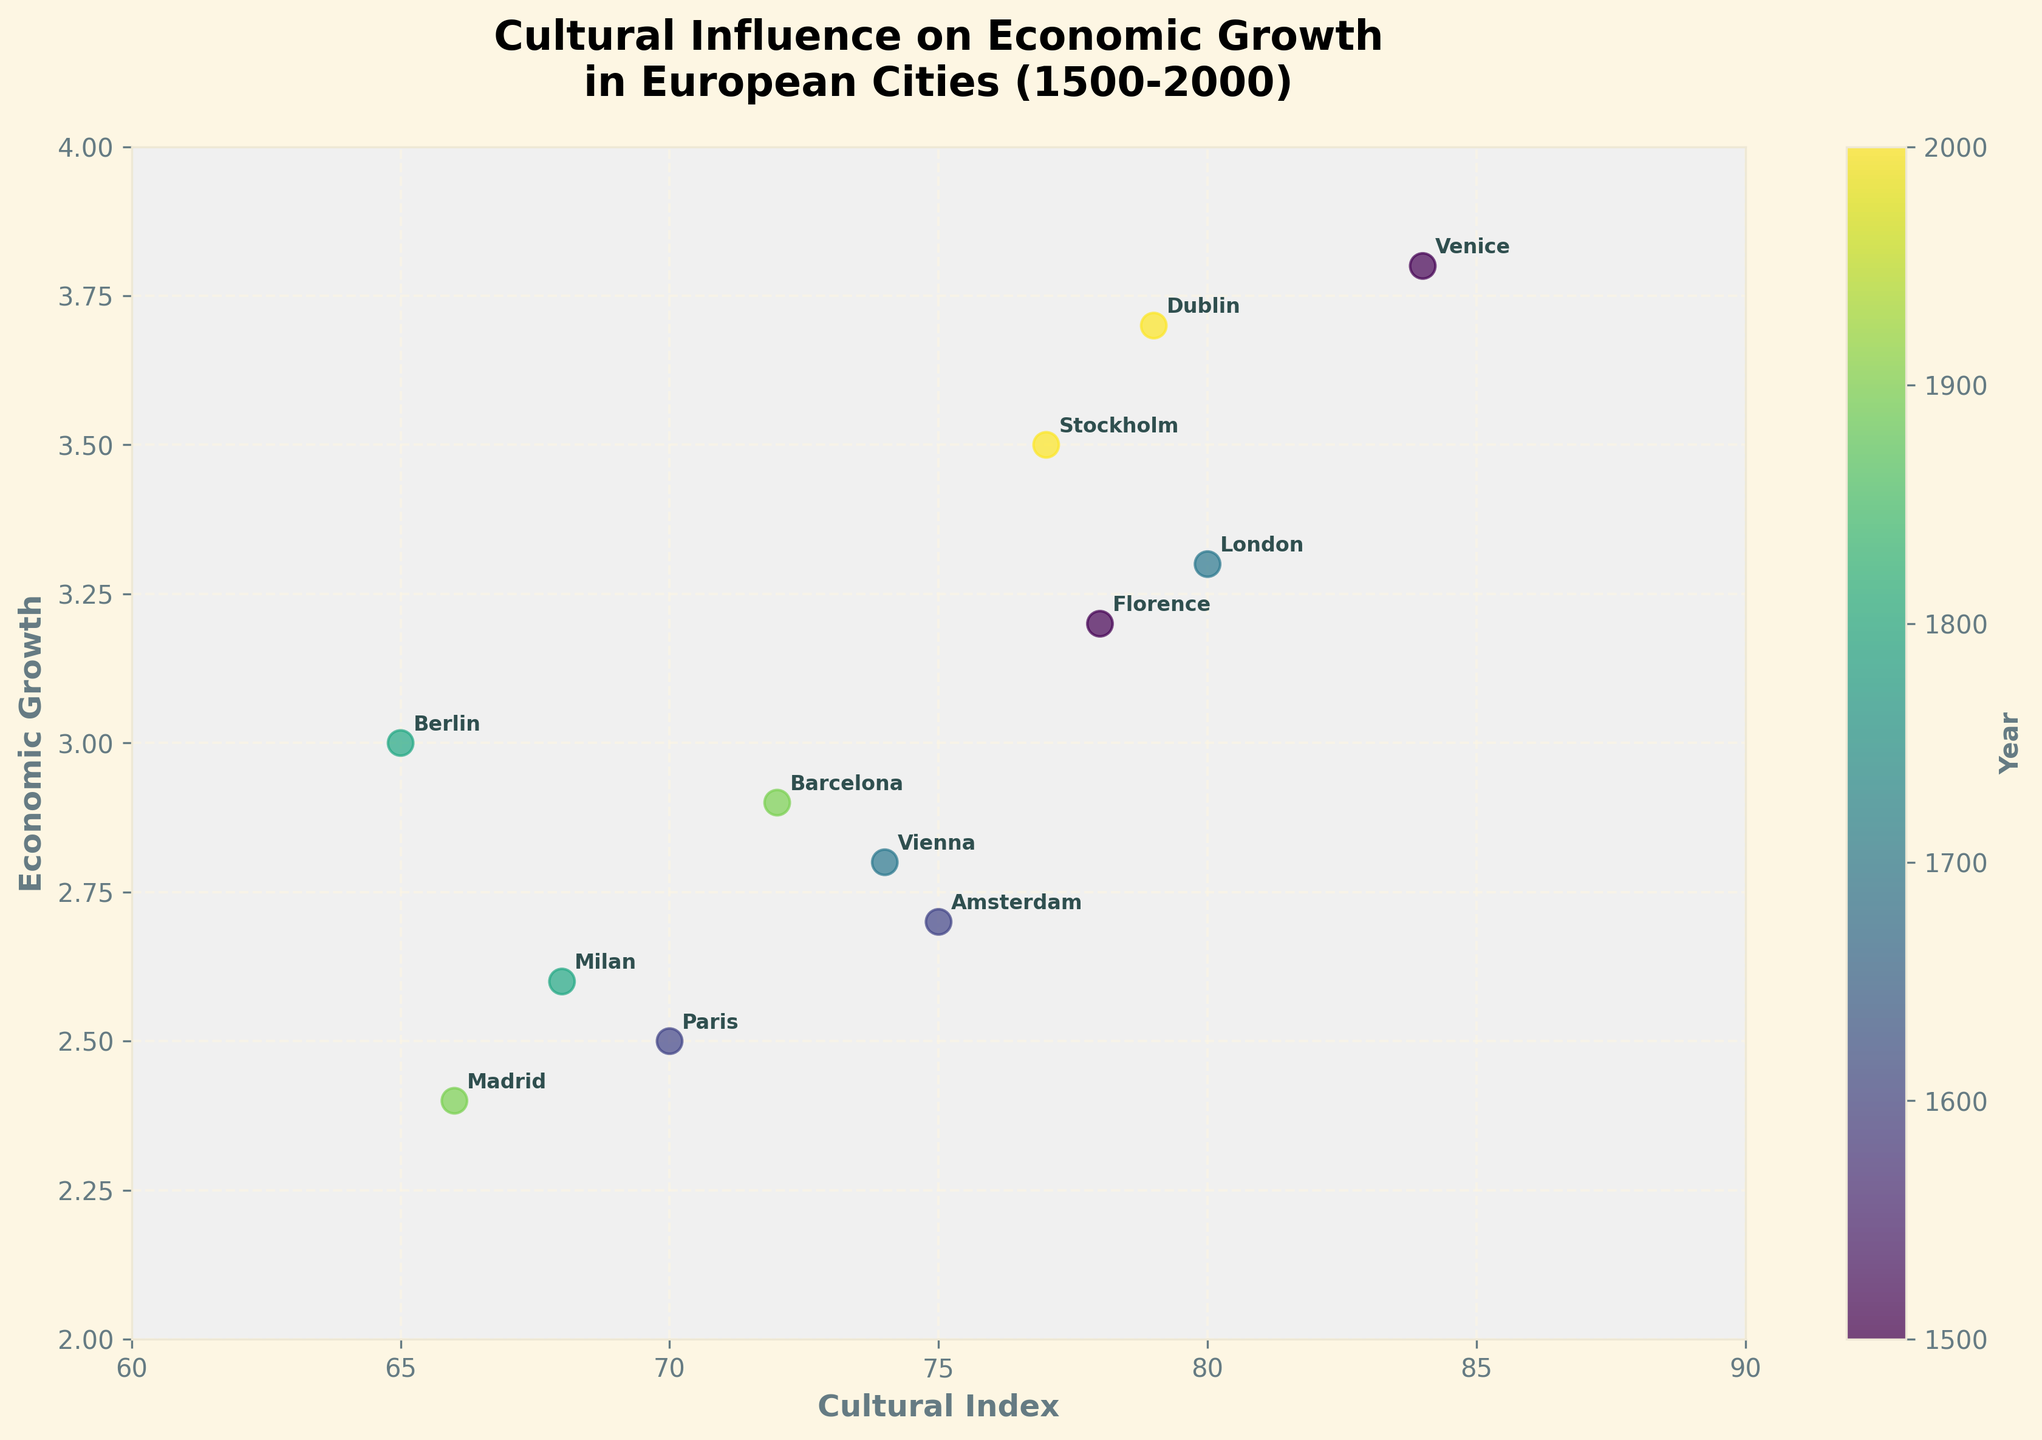Which city has the highest Cultural Index in 1500? Florence and Venice are the cities listed in 1500. Among them, Venice has a Cultural Index of 84, which is higher than Florence's 78.
Answer: Venice What is the overall trend between Cultural Index and Economic Growth? Observing the scatter plot, higher Cultural Index values generally correspond to higher Economic Growth values, indicating a positive correlation between these variables.
Answer: Positive correlation Compare the Economic Growth of Florence and Dublin. Which city has higher growth? Florence has an Economic Growth of 3.2, and Dublin has an Economic Growth of 3.7. Comparing these values, Dublin has higher growth.
Answer: Dublin What is the average Economic Growth for the cities listed in 1900? The cities listed in 1900 are Barcelona and Madrid. Their Economic Growth values are 2.9 and 2.4, respectively. The average is (2.9 + 2.4) / 2 = 2.65.
Answer: 2.65 How does the Economic Growth of Berlin in 1800 compare to that of Vienna in 1700? Berlin's Economic Growth in 1800 is 3.0, while Vienna's is 2.8 in 1700. Comparing these values, Berlin's Economic Growth is higher.
Answer: Berlin Which city has the lowest Economic Growth, and what is its Cultural Index? Madrid has the lowest Economic Growth of 2.4. Its Cultural Index is 66.
Answer: Madrid, 66 What is the difference in Cultural Index between Florence in 1500 and Berlin in 1800? Florence's Cultural Index in 1500 is 78, and Berlin's in 1800 is 65. The difference is 78 - 65 = 13.
Answer: 13 How many cities have an Economic Growth higher than 3.0? The cities with Economic Growth higher than 3.0 include Florence, Venice, London, Berlin, Stockholm, and Dublin. Counting these cities, there are 6 in total.
Answer: 6 What is the range of the Cultural Index values in the dataset? The smallest Cultural Index value is 65 (Berlin), and the largest is 84 (Venice). The range is 84 - 65 = 19.
Answer: 19 Which city's Economic Growth is closest to the median Economic Growth value in the dataset? The sorted Economic Growth values are 2.4, 2.5, 2.6, 2.7, 2.8, 2.9, 3.0, 3.2, 3.3, 3.5, 3.7, 3.8. The median value is the average of the 6th and 7th values: (2.9 + 3.0) / 2 = 2.95. The nearest value is Barcelona with Economic Growth of 2.9.
Answer: Barcelona 